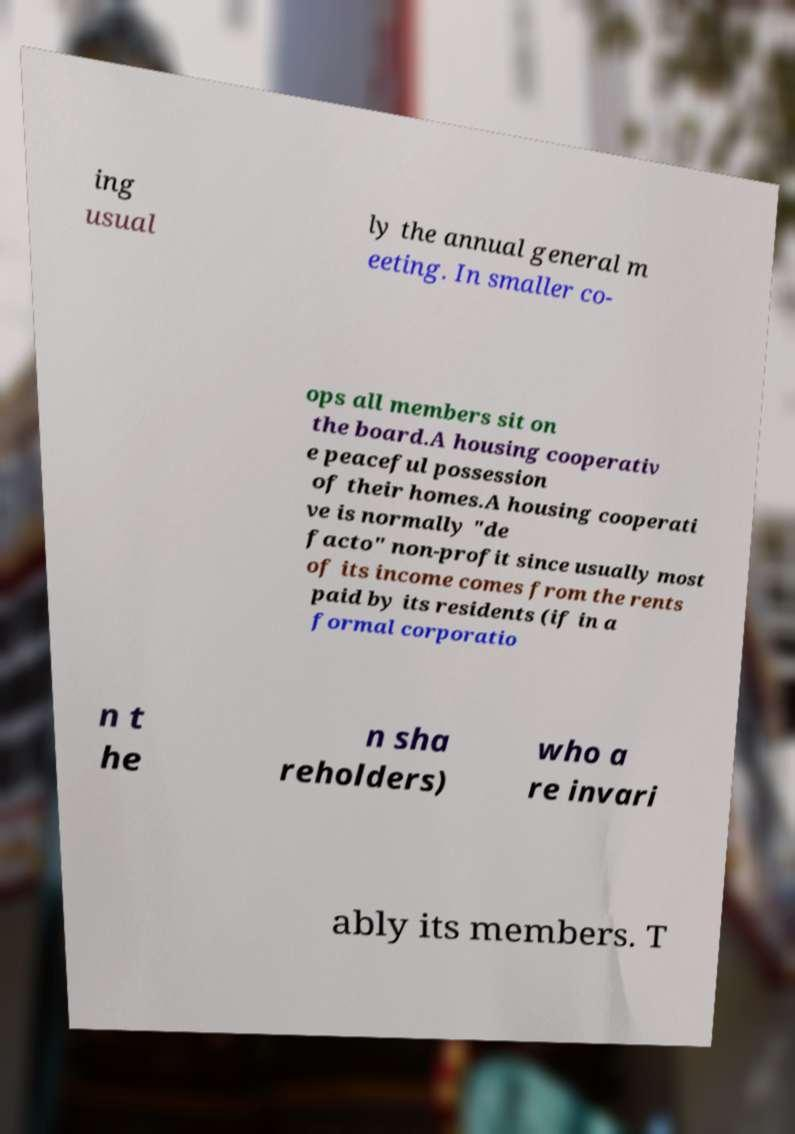Could you assist in decoding the text presented in this image and type it out clearly? ing usual ly the annual general m eeting. In smaller co- ops all members sit on the board.A housing cooperativ e peaceful possession of their homes.A housing cooperati ve is normally "de facto" non-profit since usually most of its income comes from the rents paid by its residents (if in a formal corporatio n t he n sha reholders) who a re invari ably its members. T 